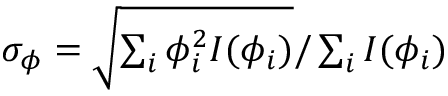Convert formula to latex. <formula><loc_0><loc_0><loc_500><loc_500>\begin{array} { r } { \sigma _ { \phi } = \sqrt { \sum _ { i } \phi _ { i } ^ { 2 } I ( \phi _ { i } ) } / \sum _ { i } I ( \phi _ { i } ) } \end{array}</formula> 